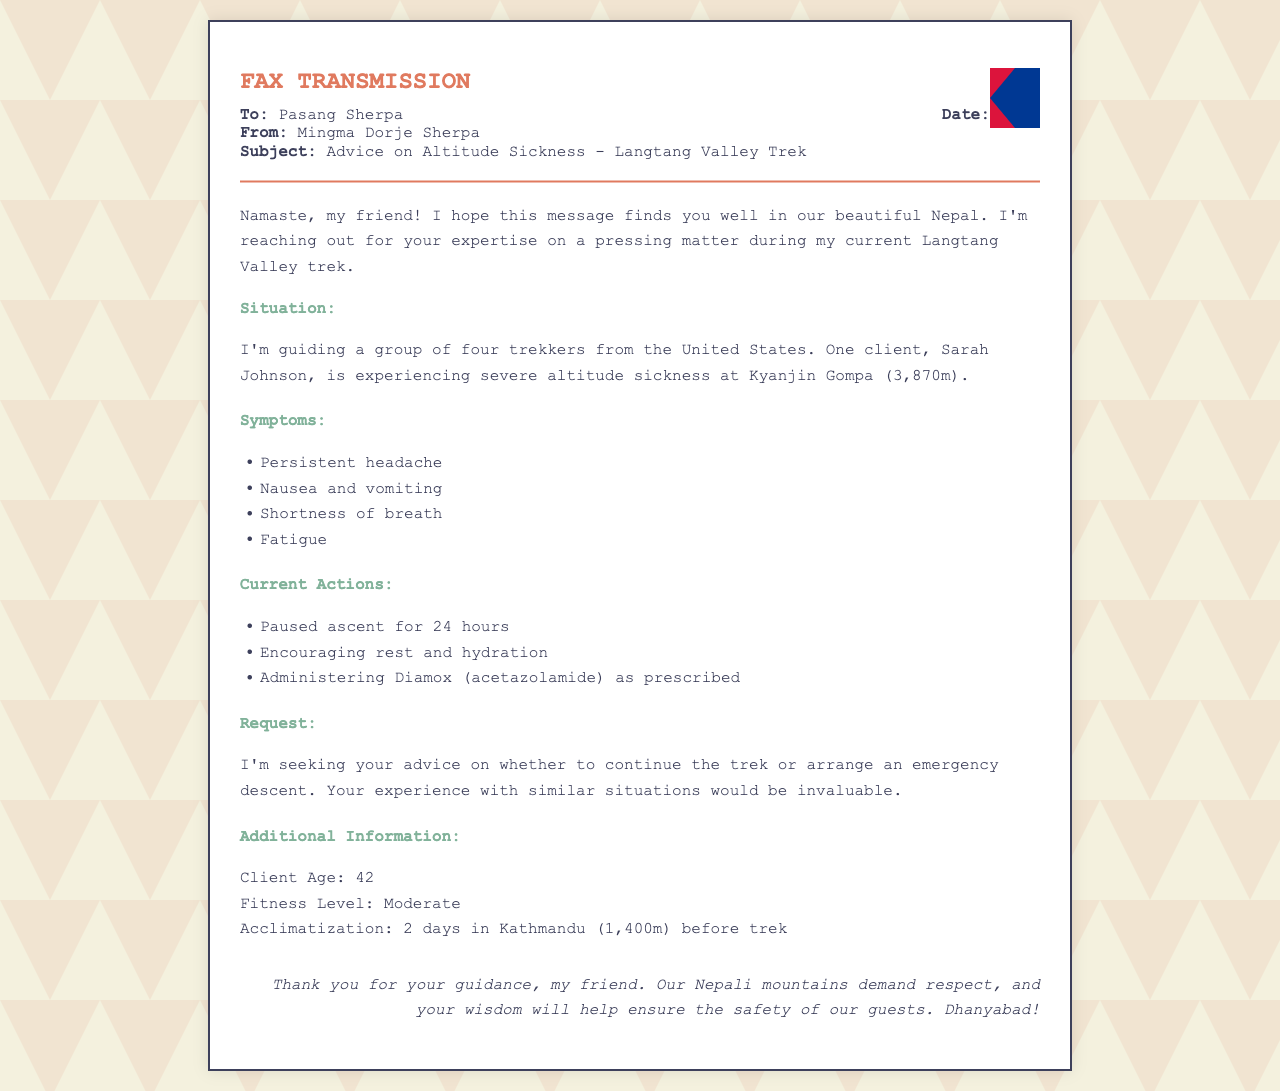What is the name of the client experiencing altitude sickness? The document specifies that the client experiencing altitude sickness is named Sarah Johnson.
Answer: Sarah Johnson What is the altitude at Kyanjin Gompa? The document states that Kyanjin Gompa is at an altitude of 3,870 meters.
Answer: 3,870m What symptoms is Sarah Johnson experiencing? The document lists persistent headache, nausea and vomiting, shortness of breath, and fatigue as symptoms experienced by Sarah.
Answer: Persistent headache, nausea and vomiting, shortness of breath, fatigue What actions have been taken regarding the client's situation? The document describes actions such as pausing ascent for 24 hours, encouraging rest and hydration, and administering Diamox.
Answer: Paused ascent for 24 hours, encouraging rest and hydration, administering Diamox How many trekkers is Mingma Dorje guiding? The document mentions that Mingma Dorje is guiding a group of four trekkers.
Answer: Four What is the fitness level of the client? The document states that the client has a moderate fitness level.
Answer: Moderate What is the primary request made by Mingma Dorje? The document indicates that Mingma Dorje is seeking advice on whether to continue the trek or arrange an emergency descent.
Answer: Continue the trek or arrange an emergency descent What does "Namaste" mean in the context of the document? "Namaste" is a common greeting in Nepal, often used to convey respect and goodwill, indicating the friendly tone of the communication.
Answer: Greeting What type of document is this? The document is a fax transmission regarding advice on altitude sickness during a trek.
Answer: Fax transmission 